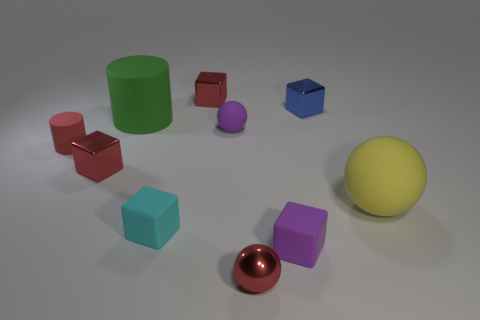What shapes are present in the image? The image contains a variety of geometric shapes. There is a cylinder, cubes, spheres, and what looks like a capsule or pill-shaped object. 